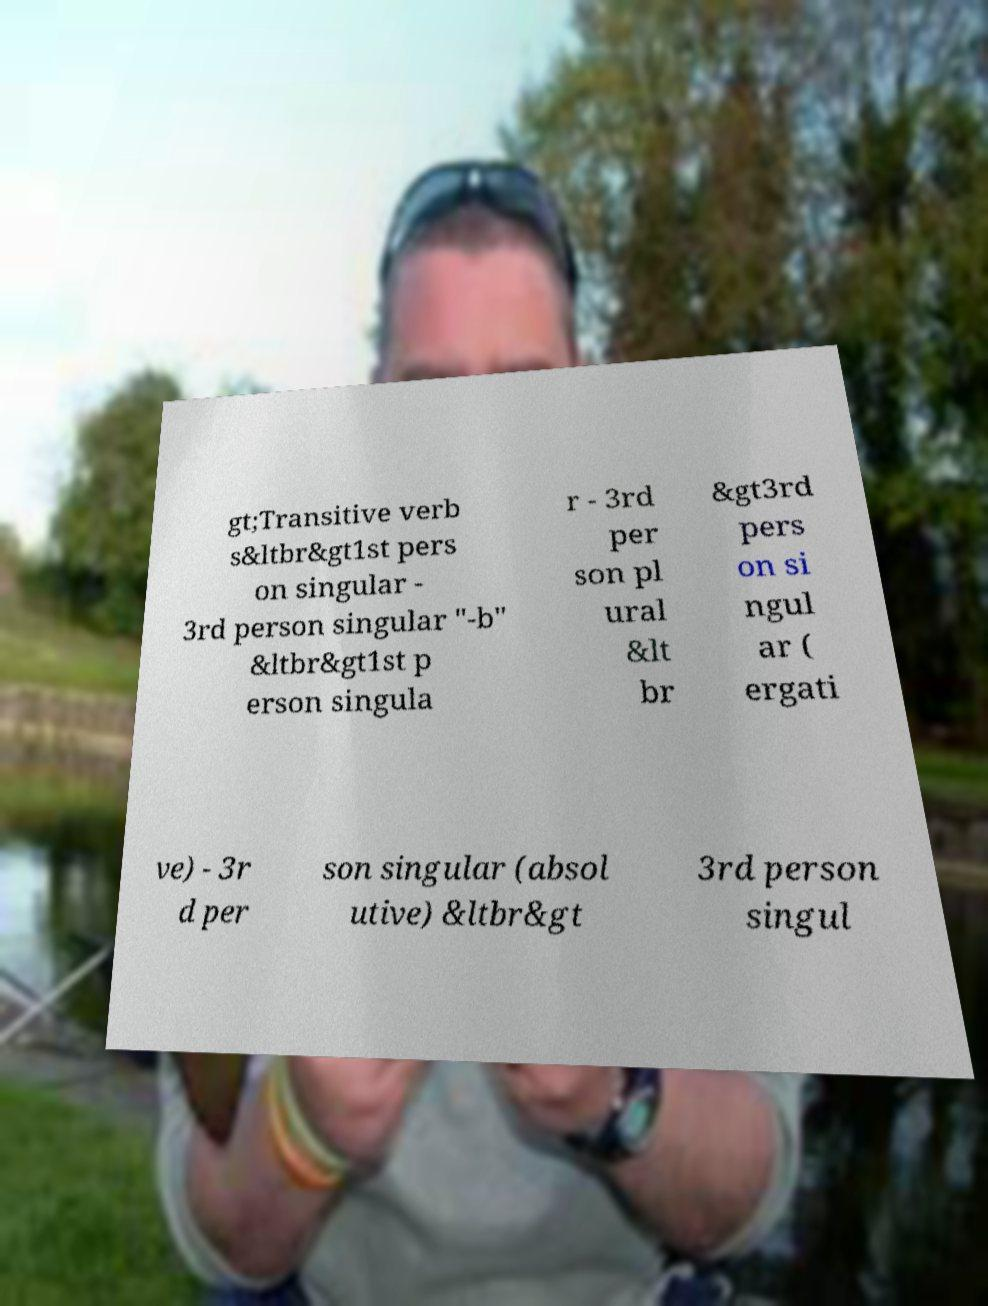Could you extract and type out the text from this image? gt;Transitive verb s&ltbr&gt1st pers on singular - 3rd person singular "-b" &ltbr&gt1st p erson singula r - 3rd per son pl ural &lt br &gt3rd pers on si ngul ar ( ergati ve) - 3r d per son singular (absol utive) &ltbr&gt 3rd person singul 